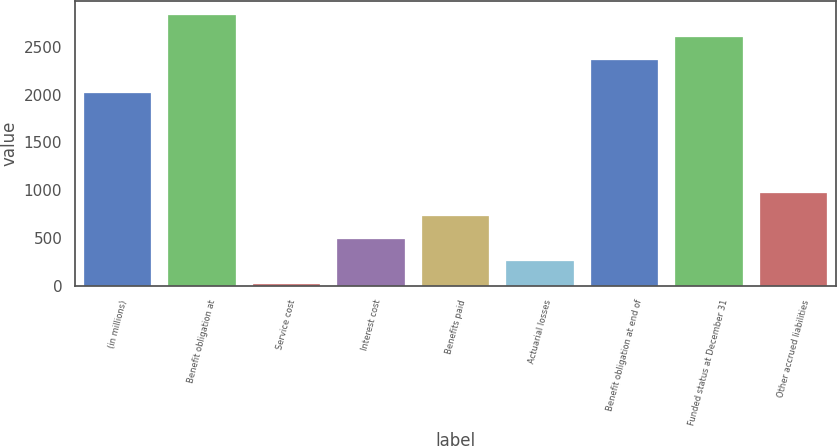Convert chart. <chart><loc_0><loc_0><loc_500><loc_500><bar_chart><fcel>(in millions)<fcel>Benefit obligation at<fcel>Service cost<fcel>Interest cost<fcel>Benefits paid<fcel>Actuarial losses<fcel>Benefit obligation at end of<fcel>Funded status at December 31<fcel>Other accrued liabilities<nl><fcel>2016<fcel>2839<fcel>17<fcel>492<fcel>729.5<fcel>254.5<fcel>2364<fcel>2601.5<fcel>967<nl></chart> 